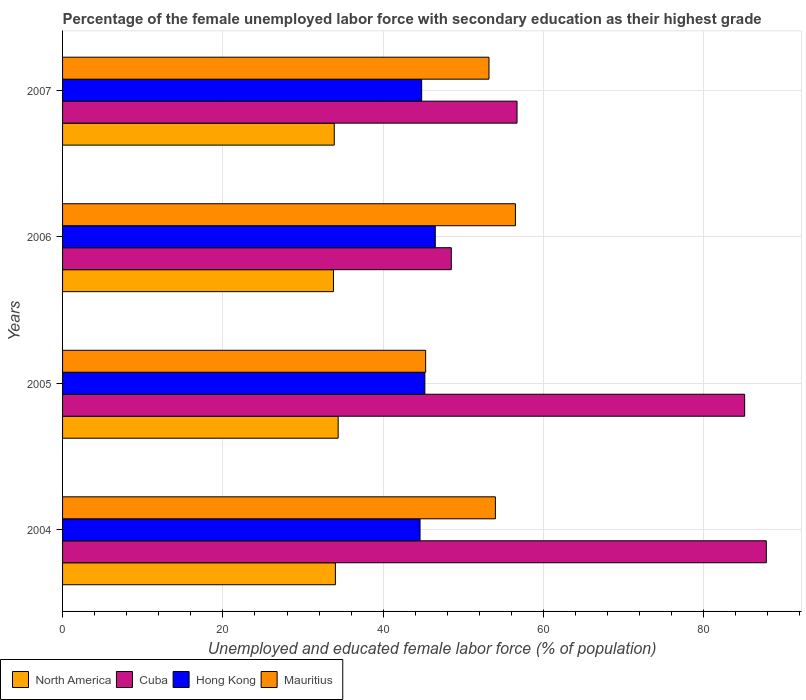How many different coloured bars are there?
Make the answer very short. 4. How many groups of bars are there?
Provide a short and direct response. 4. Are the number of bars per tick equal to the number of legend labels?
Provide a succinct answer. Yes. Are the number of bars on each tick of the Y-axis equal?
Provide a succinct answer. Yes. How many bars are there on the 3rd tick from the bottom?
Make the answer very short. 4. In how many cases, is the number of bars for a given year not equal to the number of legend labels?
Provide a short and direct response. 0. What is the percentage of the unemployed female labor force with secondary education in Mauritius in 2006?
Keep it short and to the point. 56.5. Across all years, what is the maximum percentage of the unemployed female labor force with secondary education in Cuba?
Make the answer very short. 87.8. Across all years, what is the minimum percentage of the unemployed female labor force with secondary education in Mauritius?
Make the answer very short. 45.3. What is the total percentage of the unemployed female labor force with secondary education in North America in the graph?
Your answer should be very brief. 136.12. What is the difference between the percentage of the unemployed female labor force with secondary education in Hong Kong in 2006 and that in 2007?
Your response must be concise. 1.7. What is the difference between the percentage of the unemployed female labor force with secondary education in North America in 2005 and the percentage of the unemployed female labor force with secondary education in Hong Kong in 2007?
Make the answer very short. -10.42. What is the average percentage of the unemployed female labor force with secondary education in Mauritius per year?
Offer a terse response. 52.25. In the year 2006, what is the difference between the percentage of the unemployed female labor force with secondary education in Mauritius and percentage of the unemployed female labor force with secondary education in North America?
Provide a succinct answer. 22.7. What is the ratio of the percentage of the unemployed female labor force with secondary education in North America in 2005 to that in 2007?
Make the answer very short. 1.01. Is the difference between the percentage of the unemployed female labor force with secondary education in Mauritius in 2005 and 2006 greater than the difference between the percentage of the unemployed female labor force with secondary education in North America in 2005 and 2006?
Offer a very short reply. No. What is the difference between the highest and the lowest percentage of the unemployed female labor force with secondary education in Mauritius?
Make the answer very short. 11.2. In how many years, is the percentage of the unemployed female labor force with secondary education in North America greater than the average percentage of the unemployed female labor force with secondary education in North America taken over all years?
Your response must be concise. 2. Is the sum of the percentage of the unemployed female labor force with secondary education in North America in 2006 and 2007 greater than the maximum percentage of the unemployed female labor force with secondary education in Cuba across all years?
Make the answer very short. No. Is it the case that in every year, the sum of the percentage of the unemployed female labor force with secondary education in Hong Kong and percentage of the unemployed female labor force with secondary education in North America is greater than the sum of percentage of the unemployed female labor force with secondary education in Cuba and percentage of the unemployed female labor force with secondary education in Mauritius?
Your answer should be compact. Yes. What does the 2nd bar from the top in 2006 represents?
Ensure brevity in your answer.  Hong Kong. How many bars are there?
Your answer should be very brief. 16. Are all the bars in the graph horizontal?
Your response must be concise. Yes. How many years are there in the graph?
Your answer should be very brief. 4. Are the values on the major ticks of X-axis written in scientific E-notation?
Make the answer very short. No. Does the graph contain any zero values?
Offer a very short reply. No. Does the graph contain grids?
Keep it short and to the point. Yes. Where does the legend appear in the graph?
Offer a very short reply. Bottom left. How are the legend labels stacked?
Give a very brief answer. Horizontal. What is the title of the graph?
Make the answer very short. Percentage of the female unemployed labor force with secondary education as their highest grade. Does "Poland" appear as one of the legend labels in the graph?
Give a very brief answer. No. What is the label or title of the X-axis?
Give a very brief answer. Unemployed and educated female labor force (% of population). What is the label or title of the Y-axis?
Your answer should be very brief. Years. What is the Unemployed and educated female labor force (% of population) in North America in 2004?
Your response must be concise. 34.04. What is the Unemployed and educated female labor force (% of population) in Cuba in 2004?
Give a very brief answer. 87.8. What is the Unemployed and educated female labor force (% of population) in Hong Kong in 2004?
Ensure brevity in your answer.  44.6. What is the Unemployed and educated female labor force (% of population) in Mauritius in 2004?
Keep it short and to the point. 54. What is the Unemployed and educated female labor force (% of population) of North America in 2005?
Provide a succinct answer. 34.38. What is the Unemployed and educated female labor force (% of population) in Cuba in 2005?
Keep it short and to the point. 85.1. What is the Unemployed and educated female labor force (% of population) in Hong Kong in 2005?
Make the answer very short. 45.2. What is the Unemployed and educated female labor force (% of population) in Mauritius in 2005?
Keep it short and to the point. 45.3. What is the Unemployed and educated female labor force (% of population) of North America in 2006?
Provide a succinct answer. 33.8. What is the Unemployed and educated female labor force (% of population) in Cuba in 2006?
Your response must be concise. 48.5. What is the Unemployed and educated female labor force (% of population) of Hong Kong in 2006?
Your answer should be very brief. 46.5. What is the Unemployed and educated female labor force (% of population) of Mauritius in 2006?
Your response must be concise. 56.5. What is the Unemployed and educated female labor force (% of population) in North America in 2007?
Offer a terse response. 33.9. What is the Unemployed and educated female labor force (% of population) in Cuba in 2007?
Your answer should be compact. 56.7. What is the Unemployed and educated female labor force (% of population) of Hong Kong in 2007?
Offer a very short reply. 44.8. What is the Unemployed and educated female labor force (% of population) of Mauritius in 2007?
Your answer should be compact. 53.2. Across all years, what is the maximum Unemployed and educated female labor force (% of population) of North America?
Provide a short and direct response. 34.38. Across all years, what is the maximum Unemployed and educated female labor force (% of population) of Cuba?
Offer a terse response. 87.8. Across all years, what is the maximum Unemployed and educated female labor force (% of population) of Hong Kong?
Offer a very short reply. 46.5. Across all years, what is the maximum Unemployed and educated female labor force (% of population) in Mauritius?
Provide a succinct answer. 56.5. Across all years, what is the minimum Unemployed and educated female labor force (% of population) in North America?
Provide a short and direct response. 33.8. Across all years, what is the minimum Unemployed and educated female labor force (% of population) of Cuba?
Provide a succinct answer. 48.5. Across all years, what is the minimum Unemployed and educated female labor force (% of population) of Hong Kong?
Provide a short and direct response. 44.6. Across all years, what is the minimum Unemployed and educated female labor force (% of population) in Mauritius?
Give a very brief answer. 45.3. What is the total Unemployed and educated female labor force (% of population) in North America in the graph?
Provide a succinct answer. 136.12. What is the total Unemployed and educated female labor force (% of population) in Cuba in the graph?
Your answer should be compact. 278.1. What is the total Unemployed and educated female labor force (% of population) in Hong Kong in the graph?
Keep it short and to the point. 181.1. What is the total Unemployed and educated female labor force (% of population) in Mauritius in the graph?
Ensure brevity in your answer.  209. What is the difference between the Unemployed and educated female labor force (% of population) in North America in 2004 and that in 2005?
Offer a very short reply. -0.34. What is the difference between the Unemployed and educated female labor force (% of population) of Hong Kong in 2004 and that in 2005?
Keep it short and to the point. -0.6. What is the difference between the Unemployed and educated female labor force (% of population) in North America in 2004 and that in 2006?
Offer a very short reply. 0.24. What is the difference between the Unemployed and educated female labor force (% of population) in Cuba in 2004 and that in 2006?
Keep it short and to the point. 39.3. What is the difference between the Unemployed and educated female labor force (% of population) in Mauritius in 2004 and that in 2006?
Offer a terse response. -2.5. What is the difference between the Unemployed and educated female labor force (% of population) in North America in 2004 and that in 2007?
Keep it short and to the point. 0.14. What is the difference between the Unemployed and educated female labor force (% of population) of Cuba in 2004 and that in 2007?
Offer a terse response. 31.1. What is the difference between the Unemployed and educated female labor force (% of population) in Mauritius in 2004 and that in 2007?
Offer a very short reply. 0.8. What is the difference between the Unemployed and educated female labor force (% of population) of North America in 2005 and that in 2006?
Offer a very short reply. 0.58. What is the difference between the Unemployed and educated female labor force (% of population) in Cuba in 2005 and that in 2006?
Keep it short and to the point. 36.6. What is the difference between the Unemployed and educated female labor force (% of population) in Mauritius in 2005 and that in 2006?
Offer a terse response. -11.2. What is the difference between the Unemployed and educated female labor force (% of population) of North America in 2005 and that in 2007?
Give a very brief answer. 0.49. What is the difference between the Unemployed and educated female labor force (% of population) of Cuba in 2005 and that in 2007?
Keep it short and to the point. 28.4. What is the difference between the Unemployed and educated female labor force (% of population) in Hong Kong in 2005 and that in 2007?
Provide a short and direct response. 0.4. What is the difference between the Unemployed and educated female labor force (% of population) of North America in 2006 and that in 2007?
Keep it short and to the point. -0.1. What is the difference between the Unemployed and educated female labor force (% of population) in Cuba in 2006 and that in 2007?
Keep it short and to the point. -8.2. What is the difference between the Unemployed and educated female labor force (% of population) in North America in 2004 and the Unemployed and educated female labor force (% of population) in Cuba in 2005?
Keep it short and to the point. -51.06. What is the difference between the Unemployed and educated female labor force (% of population) of North America in 2004 and the Unemployed and educated female labor force (% of population) of Hong Kong in 2005?
Give a very brief answer. -11.16. What is the difference between the Unemployed and educated female labor force (% of population) of North America in 2004 and the Unemployed and educated female labor force (% of population) of Mauritius in 2005?
Give a very brief answer. -11.26. What is the difference between the Unemployed and educated female labor force (% of population) of Cuba in 2004 and the Unemployed and educated female labor force (% of population) of Hong Kong in 2005?
Provide a succinct answer. 42.6. What is the difference between the Unemployed and educated female labor force (% of population) of Cuba in 2004 and the Unemployed and educated female labor force (% of population) of Mauritius in 2005?
Your answer should be compact. 42.5. What is the difference between the Unemployed and educated female labor force (% of population) in Hong Kong in 2004 and the Unemployed and educated female labor force (% of population) in Mauritius in 2005?
Give a very brief answer. -0.7. What is the difference between the Unemployed and educated female labor force (% of population) in North America in 2004 and the Unemployed and educated female labor force (% of population) in Cuba in 2006?
Your response must be concise. -14.46. What is the difference between the Unemployed and educated female labor force (% of population) of North America in 2004 and the Unemployed and educated female labor force (% of population) of Hong Kong in 2006?
Provide a succinct answer. -12.46. What is the difference between the Unemployed and educated female labor force (% of population) in North America in 2004 and the Unemployed and educated female labor force (% of population) in Mauritius in 2006?
Your response must be concise. -22.46. What is the difference between the Unemployed and educated female labor force (% of population) in Cuba in 2004 and the Unemployed and educated female labor force (% of population) in Hong Kong in 2006?
Your answer should be very brief. 41.3. What is the difference between the Unemployed and educated female labor force (% of population) of Cuba in 2004 and the Unemployed and educated female labor force (% of population) of Mauritius in 2006?
Provide a succinct answer. 31.3. What is the difference between the Unemployed and educated female labor force (% of population) of North America in 2004 and the Unemployed and educated female labor force (% of population) of Cuba in 2007?
Offer a terse response. -22.66. What is the difference between the Unemployed and educated female labor force (% of population) in North America in 2004 and the Unemployed and educated female labor force (% of population) in Hong Kong in 2007?
Your answer should be very brief. -10.76. What is the difference between the Unemployed and educated female labor force (% of population) in North America in 2004 and the Unemployed and educated female labor force (% of population) in Mauritius in 2007?
Offer a terse response. -19.16. What is the difference between the Unemployed and educated female labor force (% of population) of Cuba in 2004 and the Unemployed and educated female labor force (% of population) of Hong Kong in 2007?
Your answer should be very brief. 43. What is the difference between the Unemployed and educated female labor force (% of population) in Cuba in 2004 and the Unemployed and educated female labor force (% of population) in Mauritius in 2007?
Provide a short and direct response. 34.6. What is the difference between the Unemployed and educated female labor force (% of population) in Hong Kong in 2004 and the Unemployed and educated female labor force (% of population) in Mauritius in 2007?
Provide a short and direct response. -8.6. What is the difference between the Unemployed and educated female labor force (% of population) in North America in 2005 and the Unemployed and educated female labor force (% of population) in Cuba in 2006?
Your response must be concise. -14.12. What is the difference between the Unemployed and educated female labor force (% of population) in North America in 2005 and the Unemployed and educated female labor force (% of population) in Hong Kong in 2006?
Make the answer very short. -12.12. What is the difference between the Unemployed and educated female labor force (% of population) of North America in 2005 and the Unemployed and educated female labor force (% of population) of Mauritius in 2006?
Offer a terse response. -22.12. What is the difference between the Unemployed and educated female labor force (% of population) in Cuba in 2005 and the Unemployed and educated female labor force (% of population) in Hong Kong in 2006?
Provide a short and direct response. 38.6. What is the difference between the Unemployed and educated female labor force (% of population) of Cuba in 2005 and the Unemployed and educated female labor force (% of population) of Mauritius in 2006?
Offer a terse response. 28.6. What is the difference between the Unemployed and educated female labor force (% of population) of Hong Kong in 2005 and the Unemployed and educated female labor force (% of population) of Mauritius in 2006?
Your answer should be compact. -11.3. What is the difference between the Unemployed and educated female labor force (% of population) in North America in 2005 and the Unemployed and educated female labor force (% of population) in Cuba in 2007?
Keep it short and to the point. -22.32. What is the difference between the Unemployed and educated female labor force (% of population) of North America in 2005 and the Unemployed and educated female labor force (% of population) of Hong Kong in 2007?
Provide a succinct answer. -10.42. What is the difference between the Unemployed and educated female labor force (% of population) of North America in 2005 and the Unemployed and educated female labor force (% of population) of Mauritius in 2007?
Keep it short and to the point. -18.82. What is the difference between the Unemployed and educated female labor force (% of population) of Cuba in 2005 and the Unemployed and educated female labor force (% of population) of Hong Kong in 2007?
Your answer should be compact. 40.3. What is the difference between the Unemployed and educated female labor force (% of population) in Cuba in 2005 and the Unemployed and educated female labor force (% of population) in Mauritius in 2007?
Provide a succinct answer. 31.9. What is the difference between the Unemployed and educated female labor force (% of population) in North America in 2006 and the Unemployed and educated female labor force (% of population) in Cuba in 2007?
Ensure brevity in your answer.  -22.9. What is the difference between the Unemployed and educated female labor force (% of population) of North America in 2006 and the Unemployed and educated female labor force (% of population) of Hong Kong in 2007?
Your answer should be very brief. -11. What is the difference between the Unemployed and educated female labor force (% of population) of North America in 2006 and the Unemployed and educated female labor force (% of population) of Mauritius in 2007?
Ensure brevity in your answer.  -19.4. What is the difference between the Unemployed and educated female labor force (% of population) in Hong Kong in 2006 and the Unemployed and educated female labor force (% of population) in Mauritius in 2007?
Your answer should be compact. -6.7. What is the average Unemployed and educated female labor force (% of population) in North America per year?
Keep it short and to the point. 34.03. What is the average Unemployed and educated female labor force (% of population) of Cuba per year?
Your response must be concise. 69.53. What is the average Unemployed and educated female labor force (% of population) of Hong Kong per year?
Offer a terse response. 45.27. What is the average Unemployed and educated female labor force (% of population) in Mauritius per year?
Keep it short and to the point. 52.25. In the year 2004, what is the difference between the Unemployed and educated female labor force (% of population) in North America and Unemployed and educated female labor force (% of population) in Cuba?
Keep it short and to the point. -53.76. In the year 2004, what is the difference between the Unemployed and educated female labor force (% of population) of North America and Unemployed and educated female labor force (% of population) of Hong Kong?
Provide a succinct answer. -10.56. In the year 2004, what is the difference between the Unemployed and educated female labor force (% of population) of North America and Unemployed and educated female labor force (% of population) of Mauritius?
Ensure brevity in your answer.  -19.96. In the year 2004, what is the difference between the Unemployed and educated female labor force (% of population) of Cuba and Unemployed and educated female labor force (% of population) of Hong Kong?
Your response must be concise. 43.2. In the year 2004, what is the difference between the Unemployed and educated female labor force (% of population) of Cuba and Unemployed and educated female labor force (% of population) of Mauritius?
Make the answer very short. 33.8. In the year 2005, what is the difference between the Unemployed and educated female labor force (% of population) of North America and Unemployed and educated female labor force (% of population) of Cuba?
Provide a succinct answer. -50.72. In the year 2005, what is the difference between the Unemployed and educated female labor force (% of population) in North America and Unemployed and educated female labor force (% of population) in Hong Kong?
Ensure brevity in your answer.  -10.82. In the year 2005, what is the difference between the Unemployed and educated female labor force (% of population) of North America and Unemployed and educated female labor force (% of population) of Mauritius?
Give a very brief answer. -10.92. In the year 2005, what is the difference between the Unemployed and educated female labor force (% of population) in Cuba and Unemployed and educated female labor force (% of population) in Hong Kong?
Offer a terse response. 39.9. In the year 2005, what is the difference between the Unemployed and educated female labor force (% of population) in Cuba and Unemployed and educated female labor force (% of population) in Mauritius?
Your response must be concise. 39.8. In the year 2005, what is the difference between the Unemployed and educated female labor force (% of population) of Hong Kong and Unemployed and educated female labor force (% of population) of Mauritius?
Provide a succinct answer. -0.1. In the year 2006, what is the difference between the Unemployed and educated female labor force (% of population) of North America and Unemployed and educated female labor force (% of population) of Cuba?
Make the answer very short. -14.7. In the year 2006, what is the difference between the Unemployed and educated female labor force (% of population) of North America and Unemployed and educated female labor force (% of population) of Hong Kong?
Give a very brief answer. -12.7. In the year 2006, what is the difference between the Unemployed and educated female labor force (% of population) of North America and Unemployed and educated female labor force (% of population) of Mauritius?
Offer a terse response. -22.7. In the year 2006, what is the difference between the Unemployed and educated female labor force (% of population) in Cuba and Unemployed and educated female labor force (% of population) in Hong Kong?
Provide a succinct answer. 2. In the year 2006, what is the difference between the Unemployed and educated female labor force (% of population) in Cuba and Unemployed and educated female labor force (% of population) in Mauritius?
Ensure brevity in your answer.  -8. In the year 2006, what is the difference between the Unemployed and educated female labor force (% of population) in Hong Kong and Unemployed and educated female labor force (% of population) in Mauritius?
Offer a terse response. -10. In the year 2007, what is the difference between the Unemployed and educated female labor force (% of population) of North America and Unemployed and educated female labor force (% of population) of Cuba?
Offer a terse response. -22.8. In the year 2007, what is the difference between the Unemployed and educated female labor force (% of population) of North America and Unemployed and educated female labor force (% of population) of Hong Kong?
Offer a terse response. -10.9. In the year 2007, what is the difference between the Unemployed and educated female labor force (% of population) in North America and Unemployed and educated female labor force (% of population) in Mauritius?
Your answer should be very brief. -19.3. In the year 2007, what is the difference between the Unemployed and educated female labor force (% of population) in Cuba and Unemployed and educated female labor force (% of population) in Hong Kong?
Ensure brevity in your answer.  11.9. In the year 2007, what is the difference between the Unemployed and educated female labor force (% of population) in Hong Kong and Unemployed and educated female labor force (% of population) in Mauritius?
Make the answer very short. -8.4. What is the ratio of the Unemployed and educated female labor force (% of population) in North America in 2004 to that in 2005?
Ensure brevity in your answer.  0.99. What is the ratio of the Unemployed and educated female labor force (% of population) of Cuba in 2004 to that in 2005?
Provide a short and direct response. 1.03. What is the ratio of the Unemployed and educated female labor force (% of population) in Hong Kong in 2004 to that in 2005?
Ensure brevity in your answer.  0.99. What is the ratio of the Unemployed and educated female labor force (% of population) in Mauritius in 2004 to that in 2005?
Provide a succinct answer. 1.19. What is the ratio of the Unemployed and educated female labor force (% of population) of North America in 2004 to that in 2006?
Offer a terse response. 1.01. What is the ratio of the Unemployed and educated female labor force (% of population) in Cuba in 2004 to that in 2006?
Keep it short and to the point. 1.81. What is the ratio of the Unemployed and educated female labor force (% of population) in Hong Kong in 2004 to that in 2006?
Your answer should be compact. 0.96. What is the ratio of the Unemployed and educated female labor force (% of population) of Mauritius in 2004 to that in 2006?
Make the answer very short. 0.96. What is the ratio of the Unemployed and educated female labor force (% of population) in Cuba in 2004 to that in 2007?
Provide a succinct answer. 1.55. What is the ratio of the Unemployed and educated female labor force (% of population) in Mauritius in 2004 to that in 2007?
Provide a succinct answer. 1.01. What is the ratio of the Unemployed and educated female labor force (% of population) of North America in 2005 to that in 2006?
Your answer should be very brief. 1.02. What is the ratio of the Unemployed and educated female labor force (% of population) in Cuba in 2005 to that in 2006?
Keep it short and to the point. 1.75. What is the ratio of the Unemployed and educated female labor force (% of population) of Hong Kong in 2005 to that in 2006?
Give a very brief answer. 0.97. What is the ratio of the Unemployed and educated female labor force (% of population) in Mauritius in 2005 to that in 2006?
Offer a terse response. 0.8. What is the ratio of the Unemployed and educated female labor force (% of population) in North America in 2005 to that in 2007?
Provide a short and direct response. 1.01. What is the ratio of the Unemployed and educated female labor force (% of population) of Cuba in 2005 to that in 2007?
Offer a very short reply. 1.5. What is the ratio of the Unemployed and educated female labor force (% of population) in Hong Kong in 2005 to that in 2007?
Give a very brief answer. 1.01. What is the ratio of the Unemployed and educated female labor force (% of population) of Mauritius in 2005 to that in 2007?
Give a very brief answer. 0.85. What is the ratio of the Unemployed and educated female labor force (% of population) of North America in 2006 to that in 2007?
Your answer should be compact. 1. What is the ratio of the Unemployed and educated female labor force (% of population) in Cuba in 2006 to that in 2007?
Provide a succinct answer. 0.86. What is the ratio of the Unemployed and educated female labor force (% of population) of Hong Kong in 2006 to that in 2007?
Give a very brief answer. 1.04. What is the ratio of the Unemployed and educated female labor force (% of population) of Mauritius in 2006 to that in 2007?
Provide a short and direct response. 1.06. What is the difference between the highest and the second highest Unemployed and educated female labor force (% of population) in North America?
Keep it short and to the point. 0.34. What is the difference between the highest and the second highest Unemployed and educated female labor force (% of population) in Cuba?
Your answer should be very brief. 2.7. What is the difference between the highest and the second highest Unemployed and educated female labor force (% of population) in Hong Kong?
Make the answer very short. 1.3. What is the difference between the highest and the lowest Unemployed and educated female labor force (% of population) in North America?
Give a very brief answer. 0.58. What is the difference between the highest and the lowest Unemployed and educated female labor force (% of population) in Cuba?
Ensure brevity in your answer.  39.3. What is the difference between the highest and the lowest Unemployed and educated female labor force (% of population) in Hong Kong?
Your answer should be very brief. 1.9. What is the difference between the highest and the lowest Unemployed and educated female labor force (% of population) of Mauritius?
Give a very brief answer. 11.2. 